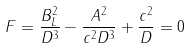<formula> <loc_0><loc_0><loc_500><loc_500>F = \frac { B _ { L } ^ { 2 } } { D ^ { 3 } } - \frac { A ^ { 2 } } { c ^ { 2 } D ^ { 3 } } + \frac { c ^ { 2 } } { D } = 0</formula> 